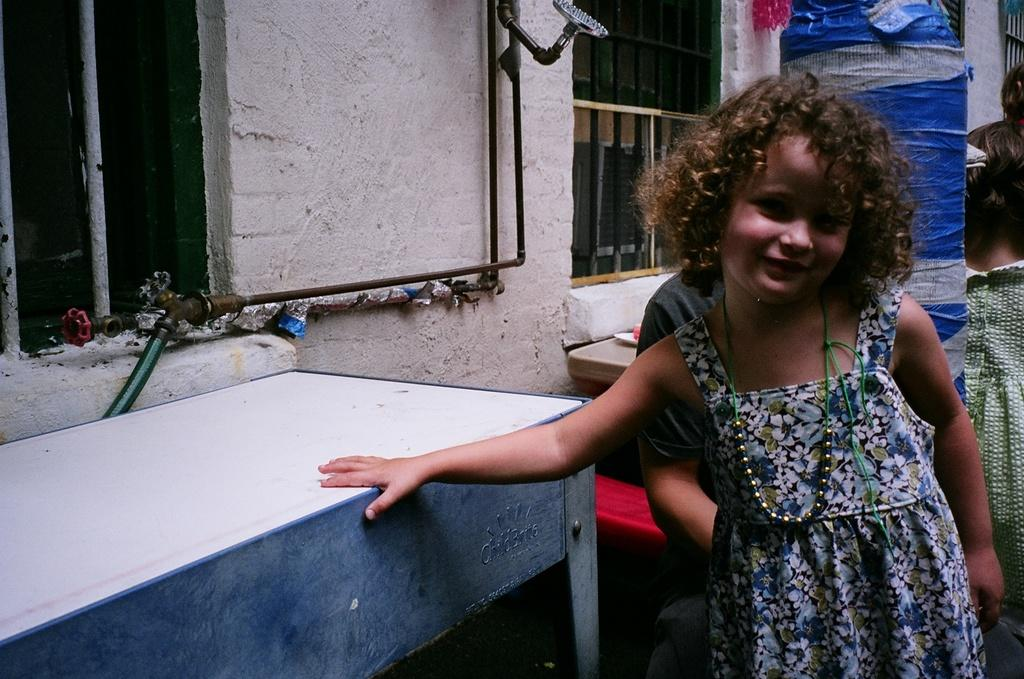Who is the main subject in the image? There is a girl in the image. What is the girl holding in the image? The girl is holding a desk. What can be seen in the background of the image? There is a blue color thing in the background and a person. What decision did the girl make before holding the desk in the image? There is no information about any decision made by the girl in the image. 